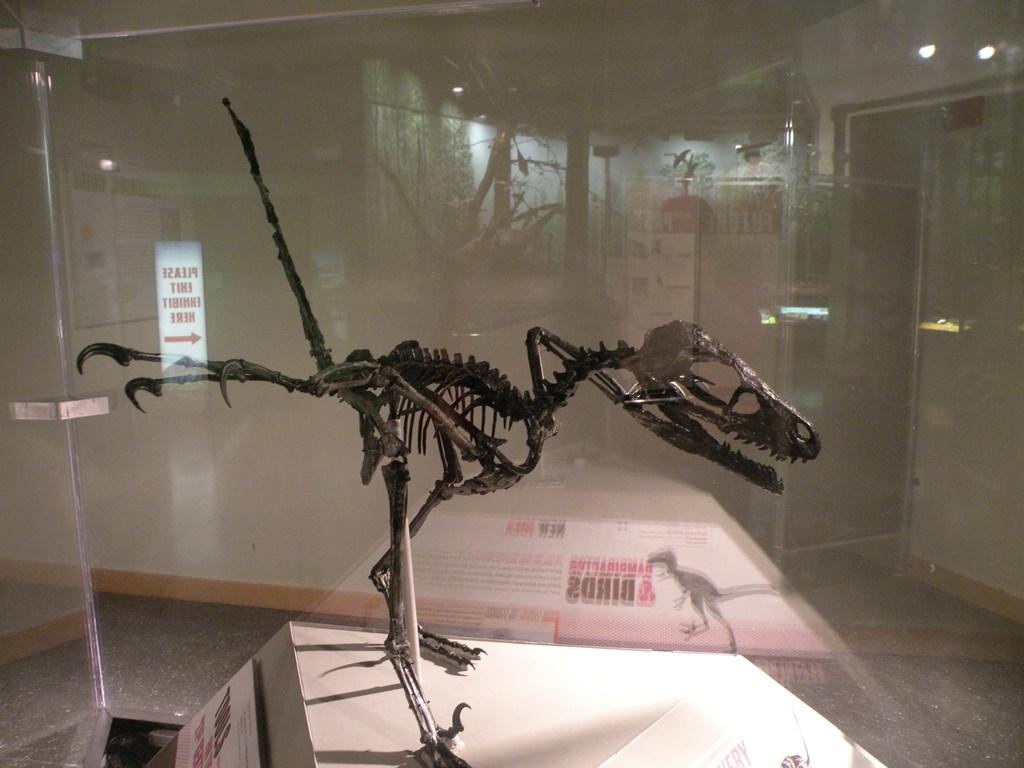What is the main subject of the image? There is a dinosaur skeleton in the image. Where is the dinosaur skeleton located in the image? The dinosaur skeleton is in the center of the image. How is the dinosaur skeleton displayed in the image? The dinosaur skeleton is inside a glass box. Can you see a trail of footprints leading to the dinosaur skeleton in the image? There is no trail of footprints visible in the image. 